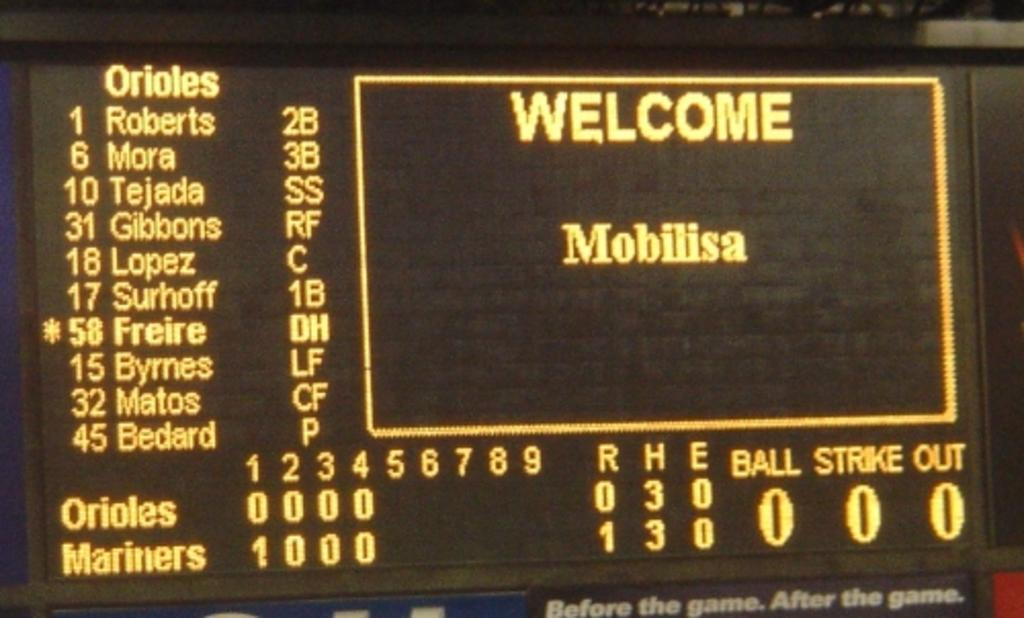What object is present in the image that contains text and numbers? There is a board in the image that contains text and numbers. What else can be seen in the image besides the board? Lights are visible in the image. What force is being applied to the sky in the image? There is no force being applied to the sky in the image, as the sky is not present in the image. 